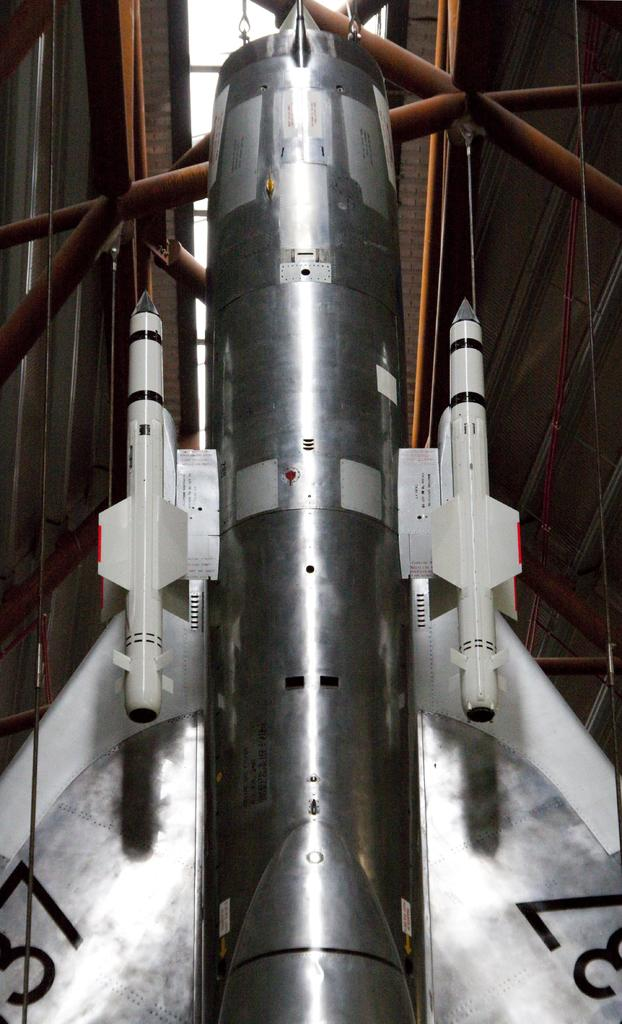What is the main subject of the image? There is a rocket in the image. Can you describe any specific features of the rocket? The image does not provide enough detail to describe specific features of the rocket. What else can be seen in the image besides the rocket? There are metal rods at the top of the image. What day of the week is depicted in the image? The image does not depict a day of the week; it features a rocket and metal rods. What type of soap is used to clean the rocket in the image? There is no soap present in the image, as it features a rocket and metal rods. 